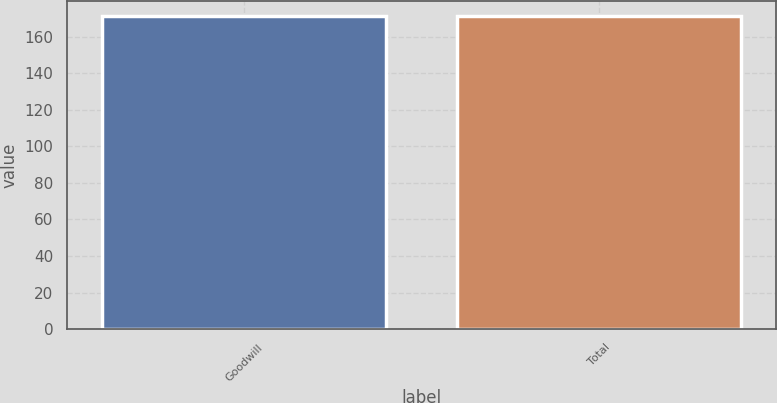Convert chart. <chart><loc_0><loc_0><loc_500><loc_500><bar_chart><fcel>Goodwill<fcel>Total<nl><fcel>171<fcel>171.1<nl></chart> 